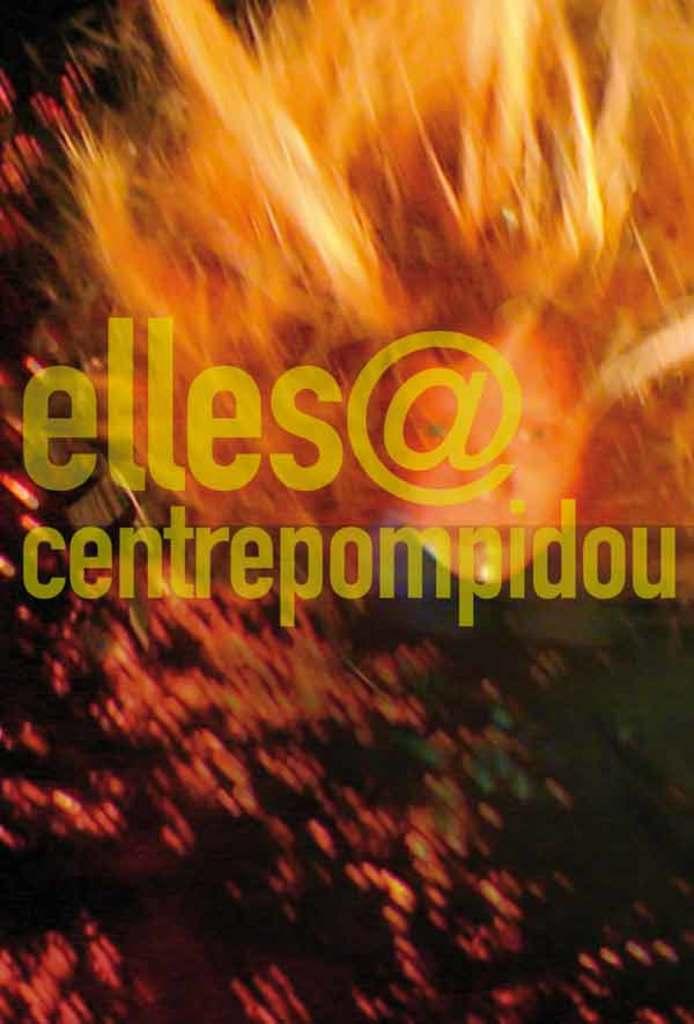What is the first name?
Your response must be concise. Elles. 